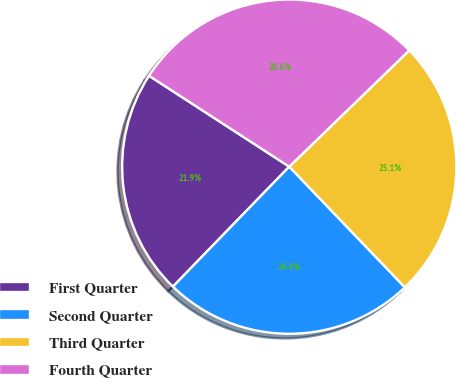Convert chart. <chart><loc_0><loc_0><loc_500><loc_500><pie_chart><fcel>First Quarter<fcel>Second Quarter<fcel>Third Quarter<fcel>Fourth Quarter<nl><fcel>21.9%<fcel>24.42%<fcel>25.09%<fcel>28.6%<nl></chart> 